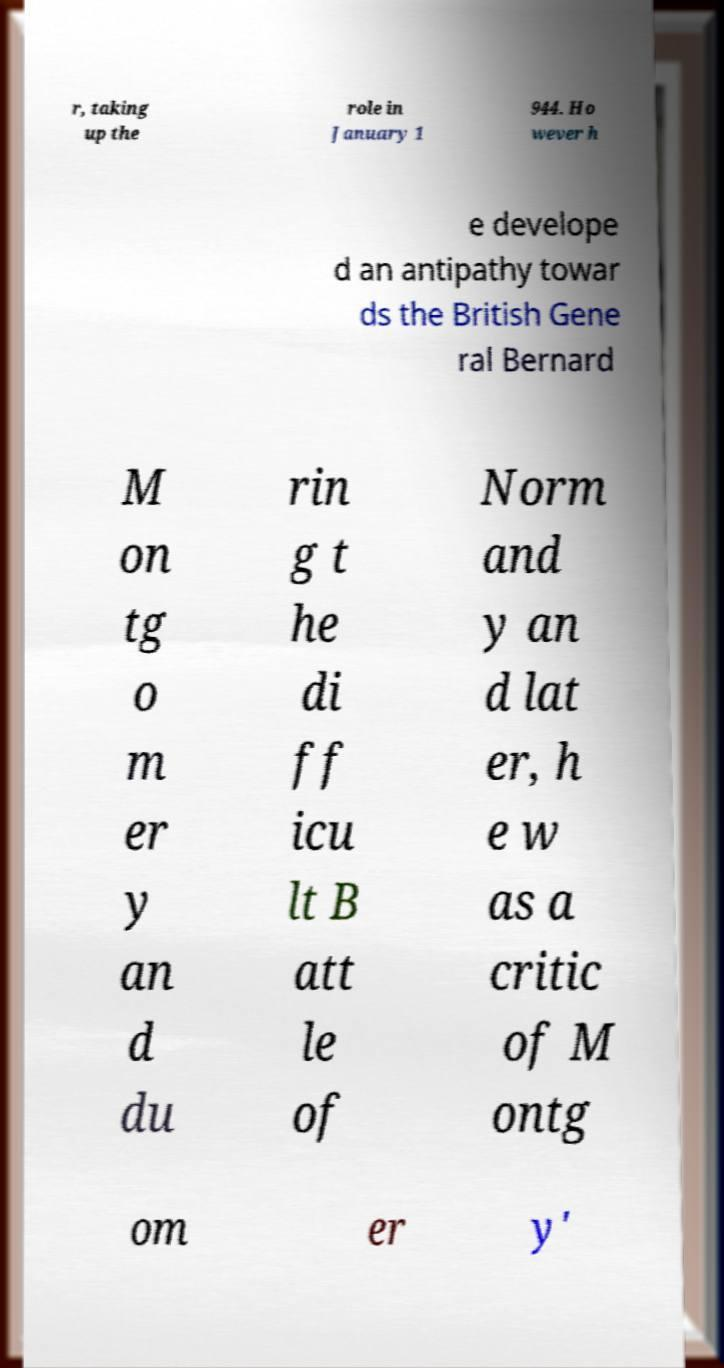What messages or text are displayed in this image? I need them in a readable, typed format. r, taking up the role in January 1 944. Ho wever h e develope d an antipathy towar ds the British Gene ral Bernard M on tg o m er y an d du rin g t he di ff icu lt B att le of Norm and y an d lat er, h e w as a critic of M ontg om er y' 